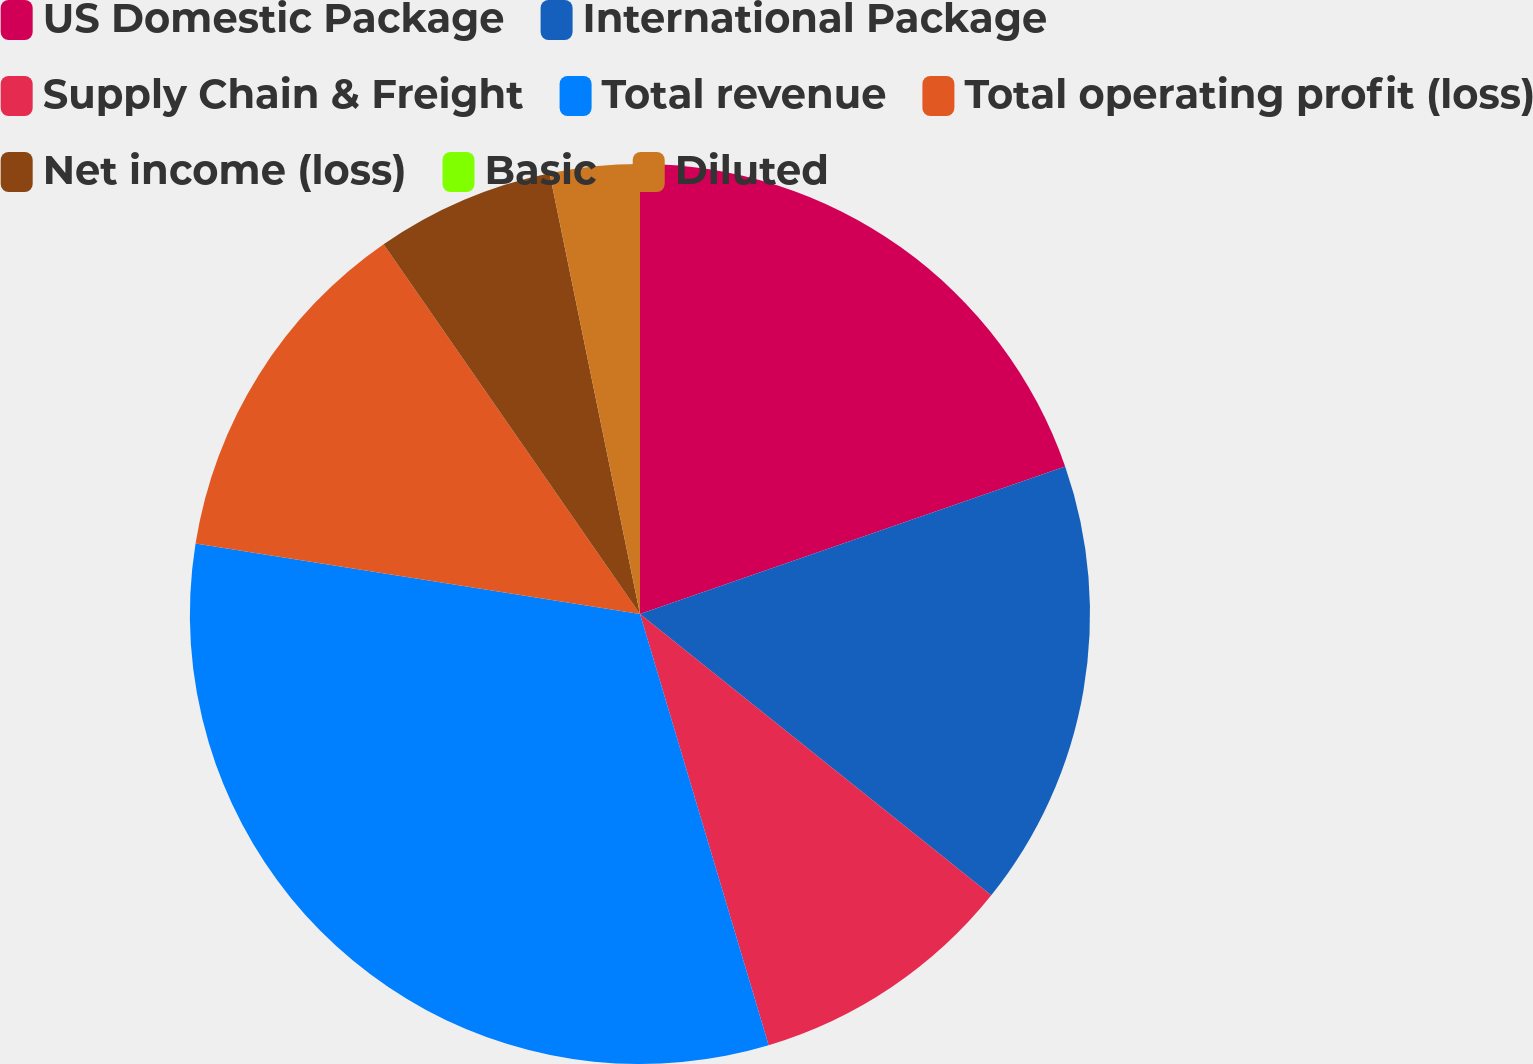Convert chart to OTSL. <chart><loc_0><loc_0><loc_500><loc_500><pie_chart><fcel>US Domestic Package<fcel>International Package<fcel>Supply Chain & Freight<fcel>Total revenue<fcel>Total operating profit (loss)<fcel>Net income (loss)<fcel>Basic<fcel>Diluted<nl><fcel>19.69%<fcel>16.06%<fcel>9.64%<fcel>32.12%<fcel>12.85%<fcel>6.43%<fcel>0.0%<fcel>3.22%<nl></chart> 